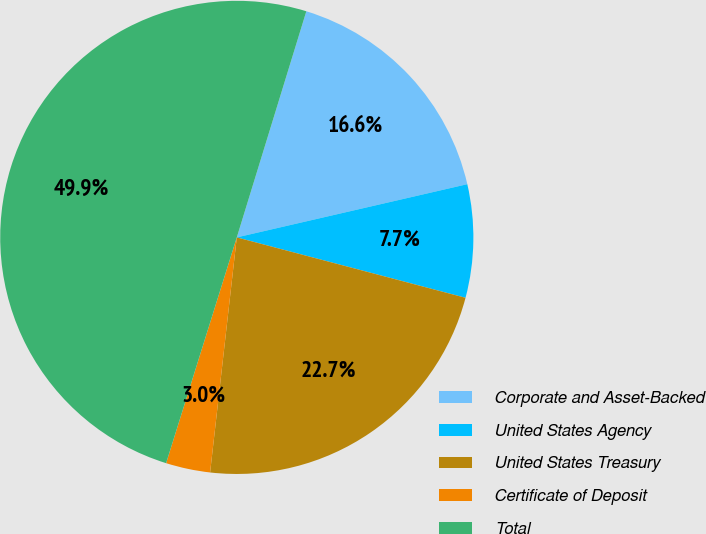Convert chart. <chart><loc_0><loc_0><loc_500><loc_500><pie_chart><fcel>Corporate and Asset-Backed<fcel>United States Agency<fcel>United States Treasury<fcel>Certificate of Deposit<fcel>Total<nl><fcel>16.64%<fcel>7.72%<fcel>22.69%<fcel>3.03%<fcel>49.92%<nl></chart> 